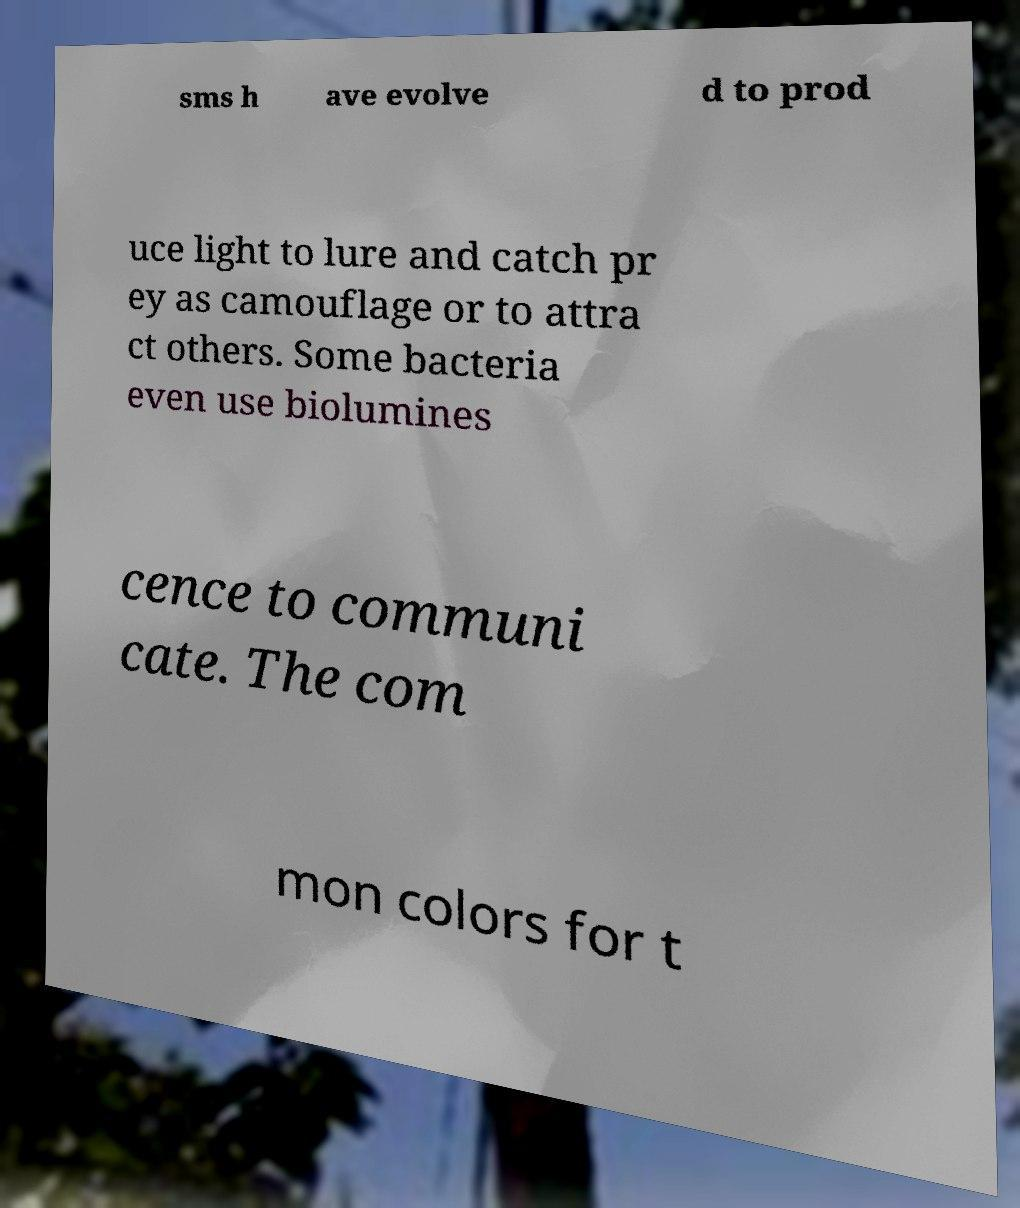For documentation purposes, I need the text within this image transcribed. Could you provide that? sms h ave evolve d to prod uce light to lure and catch pr ey as camouflage or to attra ct others. Some bacteria even use biolumines cence to communi cate. The com mon colors for t 